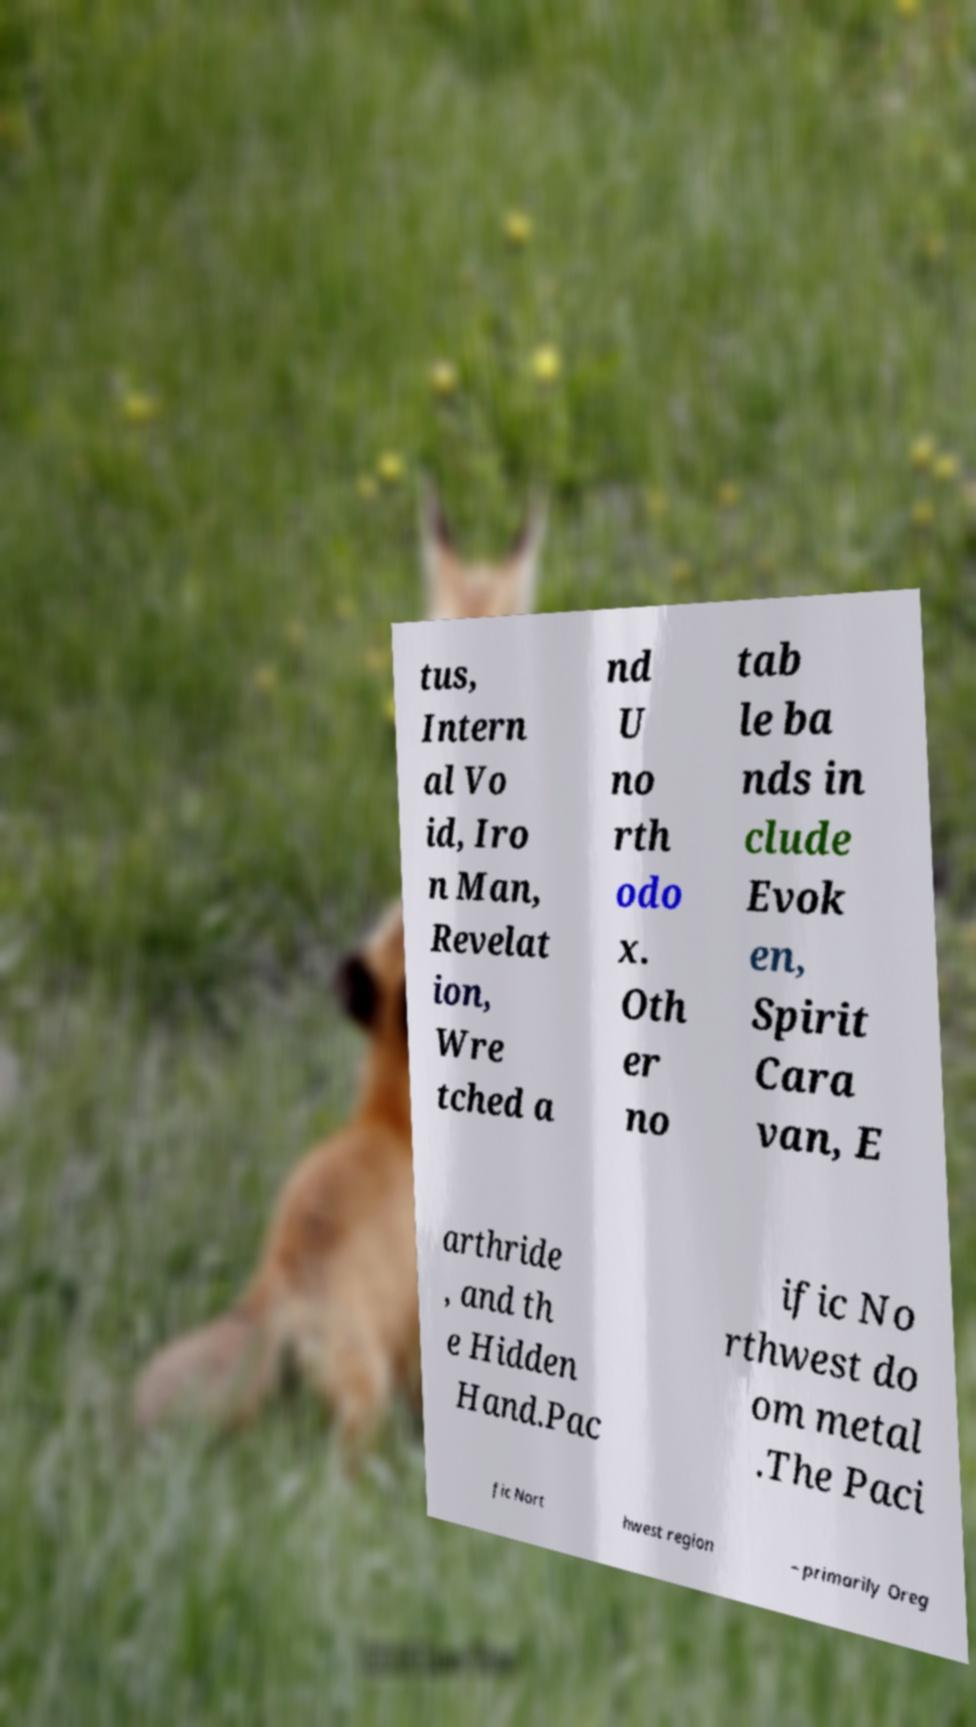There's text embedded in this image that I need extracted. Can you transcribe it verbatim? tus, Intern al Vo id, Iro n Man, Revelat ion, Wre tched a nd U no rth odo x. Oth er no tab le ba nds in clude Evok en, Spirit Cara van, E arthride , and th e Hidden Hand.Pac ific No rthwest do om metal .The Paci fic Nort hwest region – primarily Oreg 